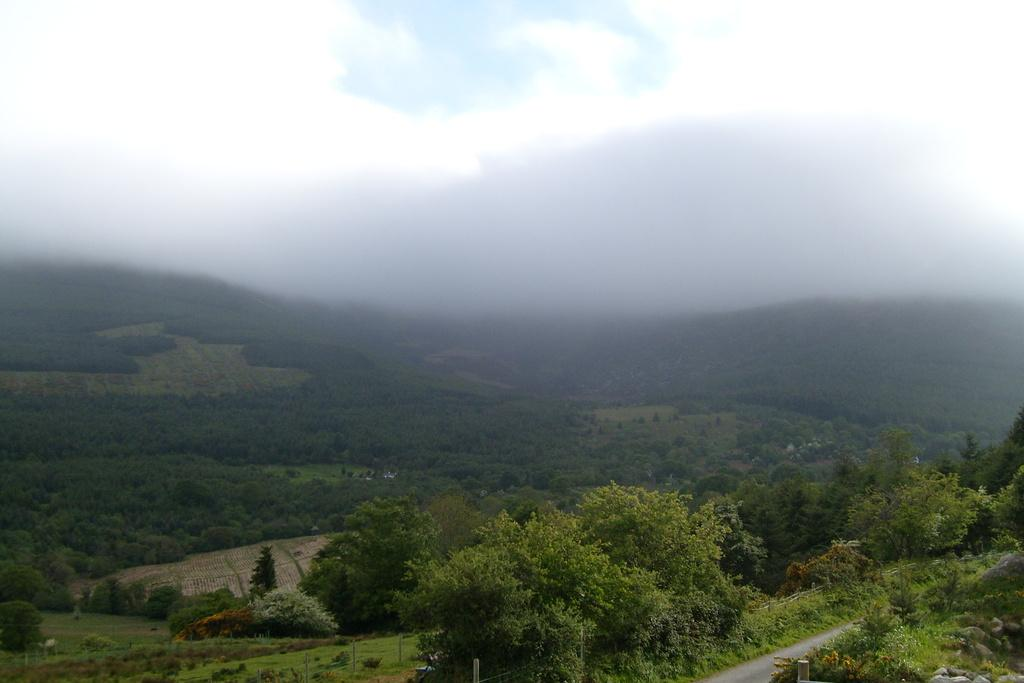What can be seen at the bottom of the picture? There are trees, plants, fields, a road, and poles at the bottom of the picture. What is present in the middle of the picture? There are fields and fog in the middle of the picture. What is visible at the top of the picture? There is fog at the top of the picture. Can you see a seat on the ship in the image? There is no ship present in the image, so there is no seat to be seen. What attempt is being made by the people in the image? There are no people visible in the image, so it is impossible to determine any attempts being made. 